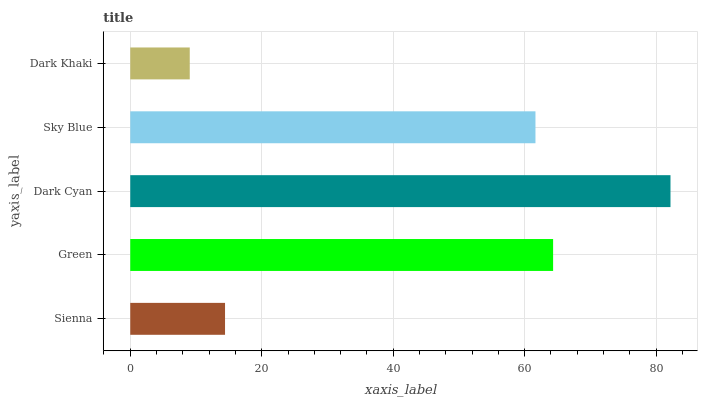Is Dark Khaki the minimum?
Answer yes or no. Yes. Is Dark Cyan the maximum?
Answer yes or no. Yes. Is Green the minimum?
Answer yes or no. No. Is Green the maximum?
Answer yes or no. No. Is Green greater than Sienna?
Answer yes or no. Yes. Is Sienna less than Green?
Answer yes or no. Yes. Is Sienna greater than Green?
Answer yes or no. No. Is Green less than Sienna?
Answer yes or no. No. Is Sky Blue the high median?
Answer yes or no. Yes. Is Sky Blue the low median?
Answer yes or no. Yes. Is Dark Cyan the high median?
Answer yes or no. No. Is Green the low median?
Answer yes or no. No. 